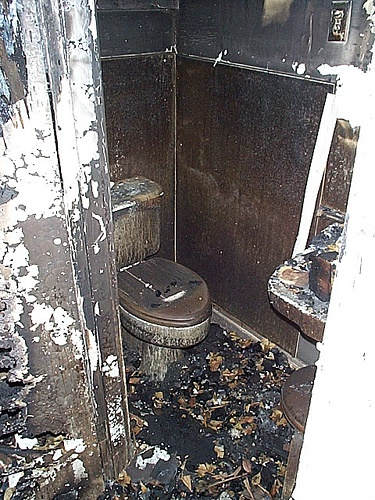Describe the objects in this image and their specific colors. I can see toilet in gray, black, and darkgray tones and sink in gray, white, darkgray, and black tones in this image. 